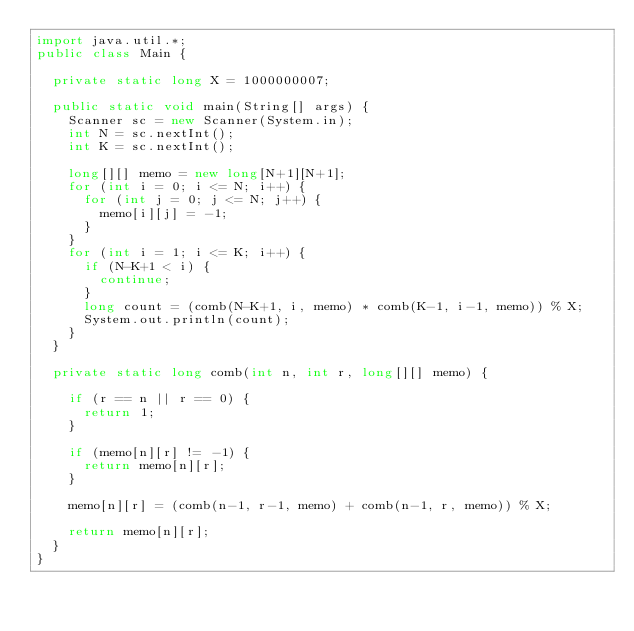<code> <loc_0><loc_0><loc_500><loc_500><_Java_>import java.util.*;
public class Main {
  
  private static long X = 1000000007;
  
  public static void main(String[] args) {
    Scanner sc = new Scanner(System.in);
    int N = sc.nextInt();
    int K = sc.nextInt();
    
    long[][] memo = new long[N+1][N+1];
    for (int i = 0; i <= N; i++) {
      for (int j = 0; j <= N; j++) {
        memo[i][j] = -1;
      }
    }
    for (int i = 1; i <= K; i++) {
      if (N-K+1 < i) {
        continue;
      }
      long count = (comb(N-K+1, i, memo) * comb(K-1, i-1, memo)) % X;
      System.out.println(count);
    }
  }
  
  private static long comb(int n, int r, long[][] memo) {

    if (r == n || r == 0) {
      return 1;
    }

    if (memo[n][r] != -1) {
      return memo[n][r];
    }
        
    memo[n][r] = (comb(n-1, r-1, memo) + comb(n-1, r, memo)) % X;
    
    return memo[n][r];
  }
}
</code> 